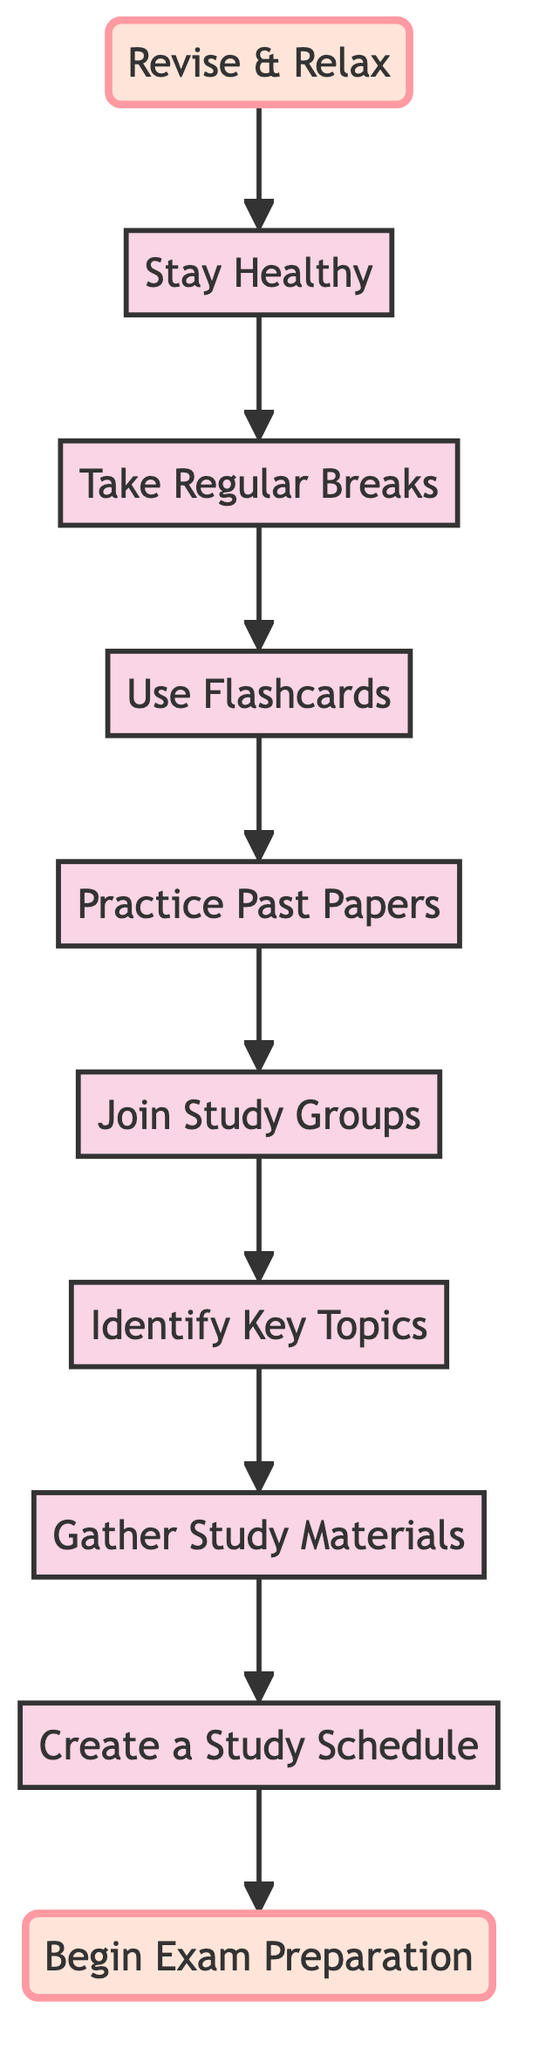What is the first step in the exam preparation process? The flowchart shows that the first step is labeled "Create a Study Schedule," which directly follows the start node.
Answer: Create a Study Schedule How many steps are present in the preparation flowchart? By counting each node between the start and finish, we find there are 8 steps: Create a Study Schedule, Gather Study Materials, Identify Key Topics, Join Study Groups, Practice Past Papers, Use Flashcards, Take Regular Breaks, and Stay Healthy.
Answer: 8 What task comes immediately after "Use Flashcards"? The flowchart indicates that the task "Take Regular Breaks" follows "Use Flashcards," as seen by the directional arrow connecting them.
Answer: Take Regular Breaks Which step is focused on health? The step labeled "Stay Healthy" specifically addresses the importance of maintaining physical and mental well-being during exam preparations, clearly shown in the diagram.
Answer: Stay Healthy How does "Practice Past Papers" relate to "Gather Study Materials"? "Practice Past Papers" occurs after "Join Study Groups," while "Gather Study Materials" is earlier in the flow. Therefore, they are connected sequentially in the study process, indicating that gathering materials comes before practicing.
Answer: Sequentially connected What action is suggested to maintain focus during study? The diagram indicates the suggested action is "Take Regular Breaks," implying that this technique helps maintain focus and avoid burnout.
Answer: Take Regular Breaks Which two steps emphasize collaborative study methods? "Join Study Groups" and "Practice Past Papers" both emphasize collaborative methods, as the former encourages group discussions, and the latter implies working with past papers that classmates may also practice together.
Answer: Join Study Groups and Practice Past Papers What is the last task before "Revise & Relax"? The last task before reaching "Revise & Relax" is "Stay Healthy," demonstrating that maintaining health is a final consideration before the revision phase.
Answer: Stay Healthy Which task focuses on reviewing important concepts? The task "Use Flashcards" directly emphasizes reviewing important definitions, formulas, and dates, aiming for quick revision of essential concepts.
Answer: Use Flashcards 